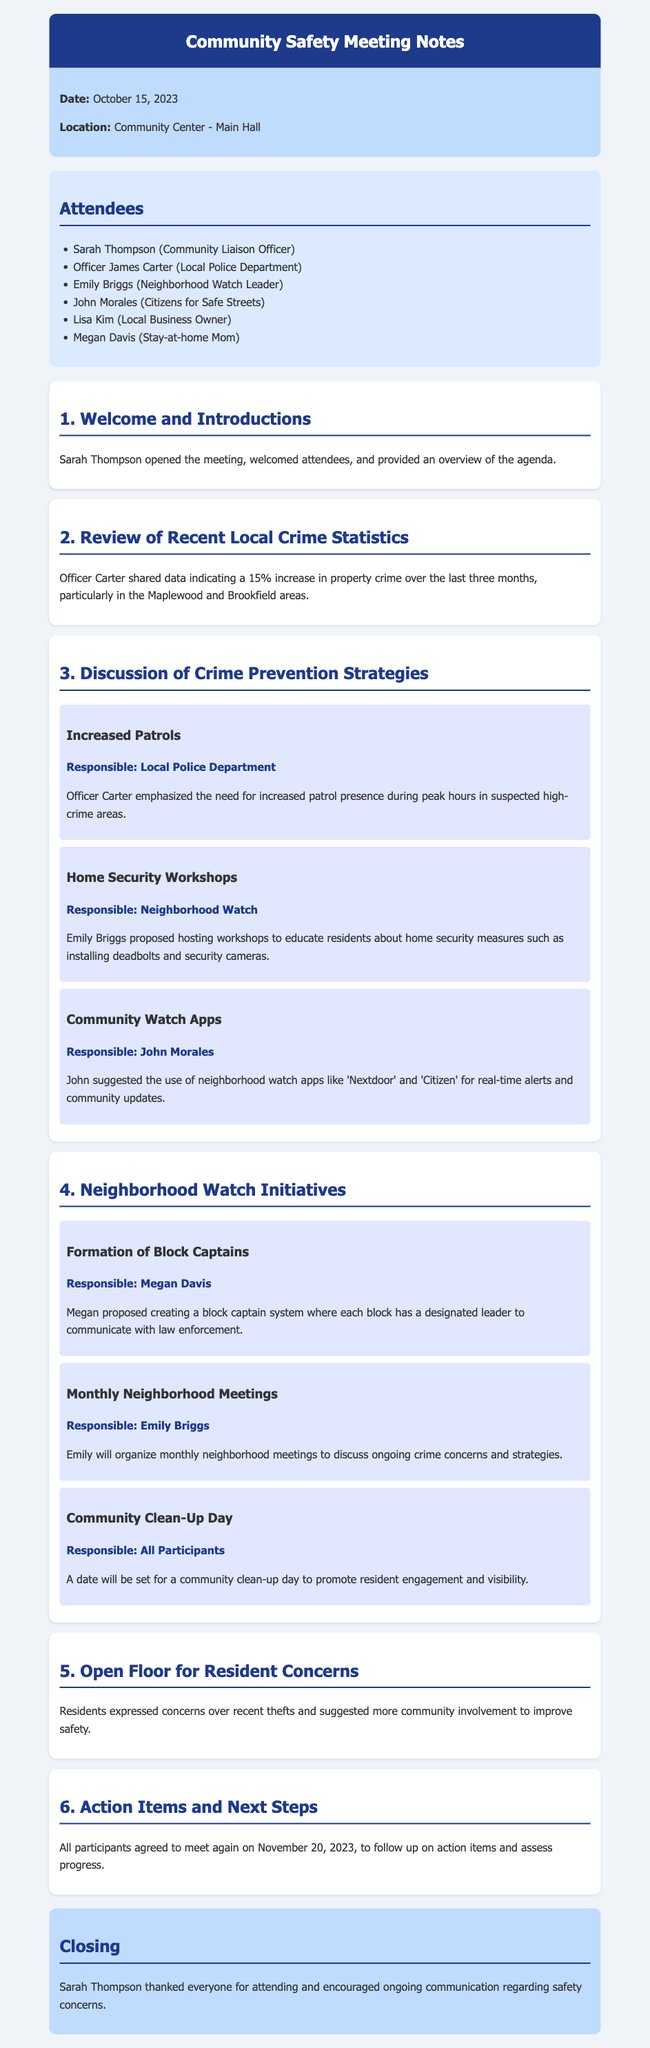What is the date of the meeting? The date of the meeting is clearly stated in the document.
Answer: October 15, 2023 Who shared the local crime statistics? The document attributes the sharing of crime statistics to a specific attendee.
Answer: Officer Carter What was the percentage increase in property crime? This statistic is mentioned in the section reviewing recent local crime statistics.
Answer: 15% Which area experienced a crime increase? The document specifies the locations affected by the crime increase.
Answer: Maplewood and Brookfield What initiative did Megan propose? Megan's proposal is detailed under the neighborhood watch initiatives.
Answer: Formation of Block Captains Who is responsible for organizing monthly neighborhood meetings? The document assigns responsibility for this initiative to a specific attendee.
Answer: Emily Briggs What community engagement activity is planned? The document mentions a planned activity to foster resident participation.
Answer: Community Clean-Up Day What is the next meeting date? The closing section indicates when the follow-up meeting will occur.
Answer: November 20, 2023 What was emphasized as a necessary crime prevention strategy? An important strategy for crime prevention is highlighted in the discussion of strategies.
Answer: Increased Patrols 